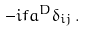<formula> <loc_0><loc_0><loc_500><loc_500>- i f a ^ { D } \delta _ { i j } \, .</formula> 